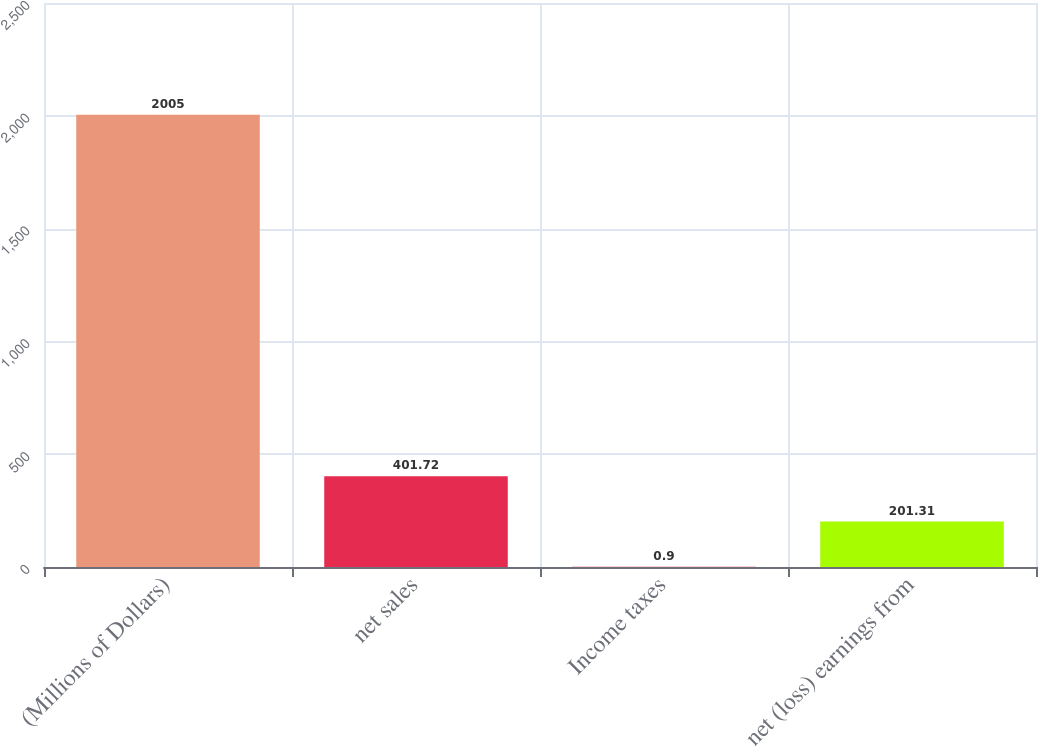Convert chart. <chart><loc_0><loc_0><loc_500><loc_500><bar_chart><fcel>(Millions of Dollars)<fcel>net sales<fcel>Income taxes<fcel>net (loss) earnings from<nl><fcel>2005<fcel>401.72<fcel>0.9<fcel>201.31<nl></chart> 